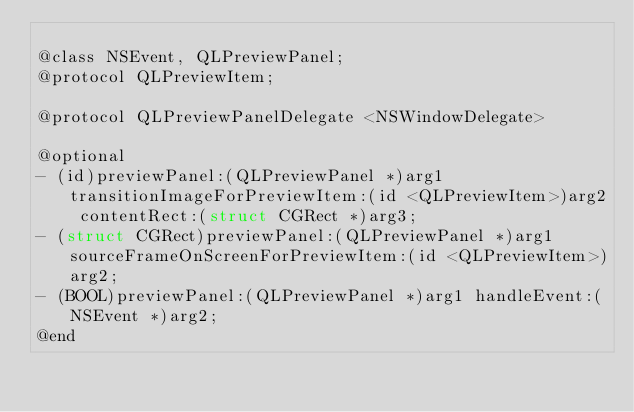Convert code to text. <code><loc_0><loc_0><loc_500><loc_500><_C_>
@class NSEvent, QLPreviewPanel;
@protocol QLPreviewItem;

@protocol QLPreviewPanelDelegate <NSWindowDelegate>

@optional
- (id)previewPanel:(QLPreviewPanel *)arg1 transitionImageForPreviewItem:(id <QLPreviewItem>)arg2 contentRect:(struct CGRect *)arg3;
- (struct CGRect)previewPanel:(QLPreviewPanel *)arg1 sourceFrameOnScreenForPreviewItem:(id <QLPreviewItem>)arg2;
- (BOOL)previewPanel:(QLPreviewPanel *)arg1 handleEvent:(NSEvent *)arg2;
@end

</code> 